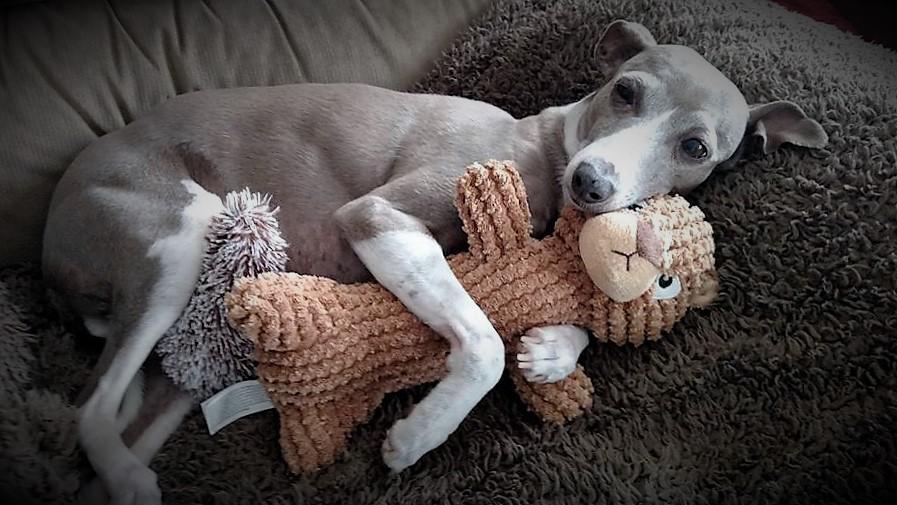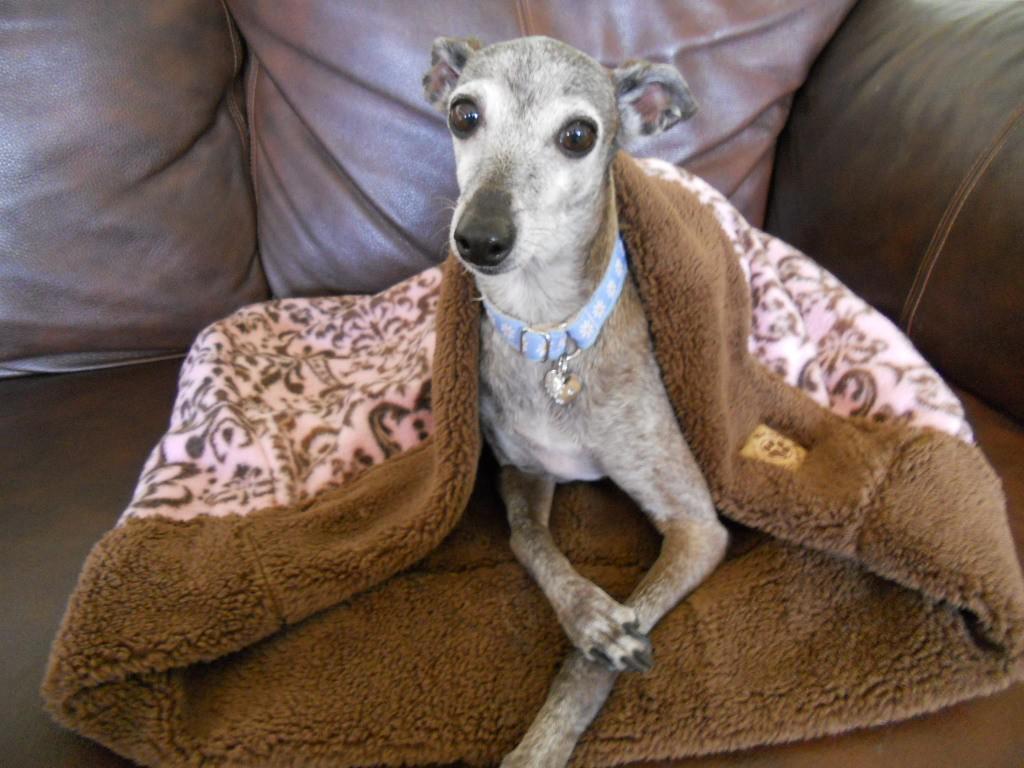The first image is the image on the left, the second image is the image on the right. For the images displayed, is the sentence "An image shows a hound hugging a stuffed animal." factually correct? Answer yes or no. Yes. The first image is the image on the left, the second image is the image on the right. For the images displayed, is the sentence "A dog in one image is cradling a stuffed animal toy while lying on a furry dark gray throw." factually correct? Answer yes or no. Yes. 